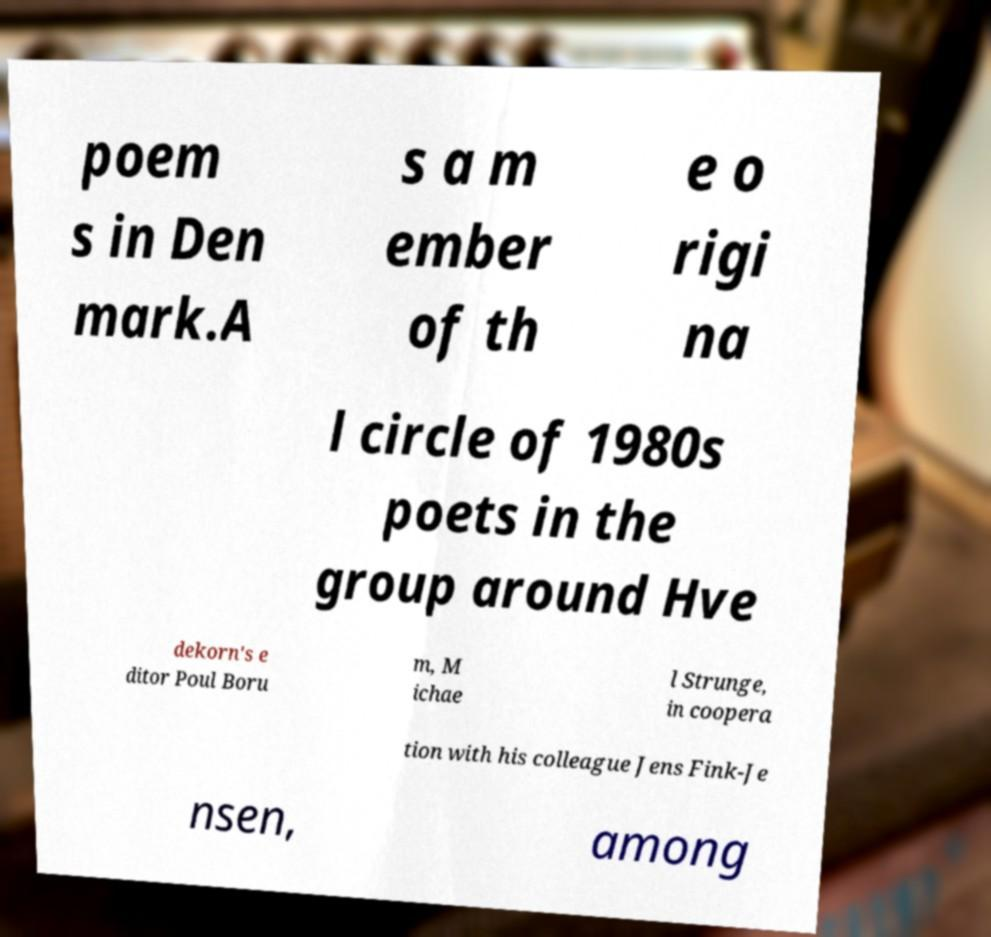Could you extract and type out the text from this image? poem s in Den mark.A s a m ember of th e o rigi na l circle of 1980s poets in the group around Hve dekorn's e ditor Poul Boru m, M ichae l Strunge, in coopera tion with his colleague Jens Fink-Je nsen, among 